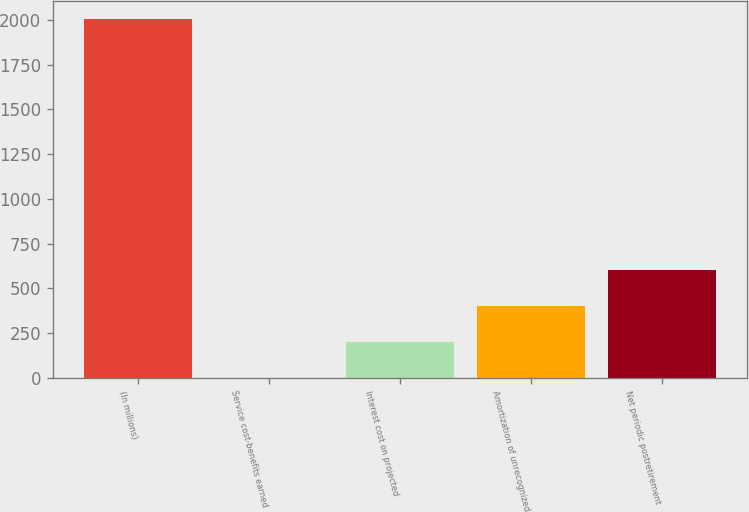Convert chart. <chart><loc_0><loc_0><loc_500><loc_500><bar_chart><fcel>(In millions)<fcel>Service cost-benefits earned<fcel>Interest cost on projected<fcel>Amortization of unrecognized<fcel>Net periodic postretirement<nl><fcel>2005<fcel>2.1<fcel>202.39<fcel>402.68<fcel>602.97<nl></chart> 